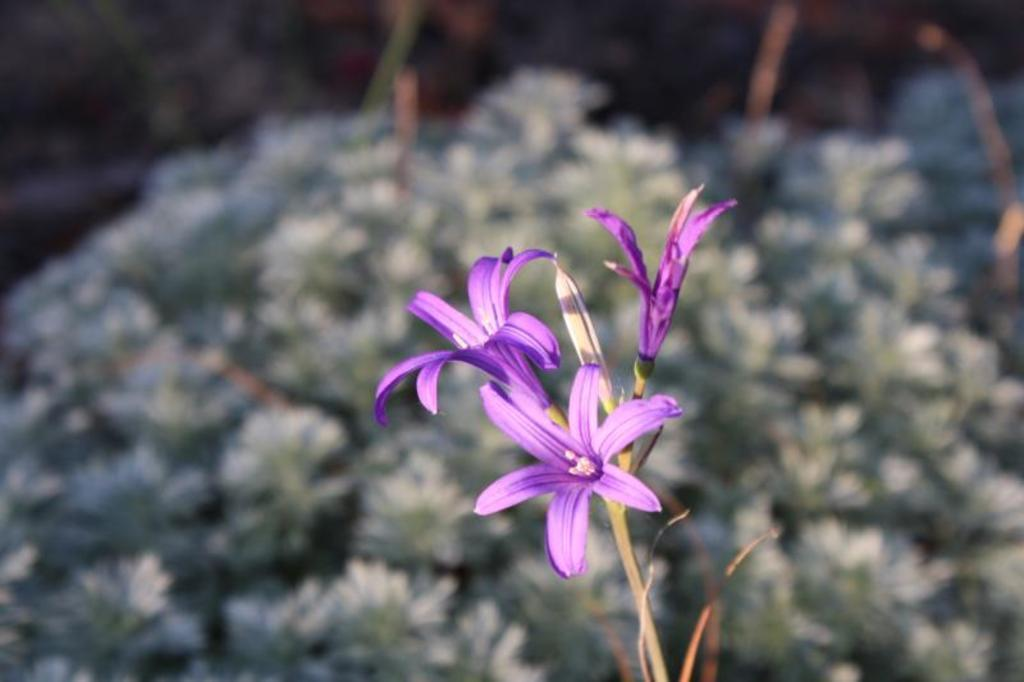What type of plants can be seen in the image? There are flowers in the image. Can you describe the structure of the flowers? The flowers have stems. What is the income of the sister in the image? There is no mention of a sister or income in the image, as it only features flowers with stems. 